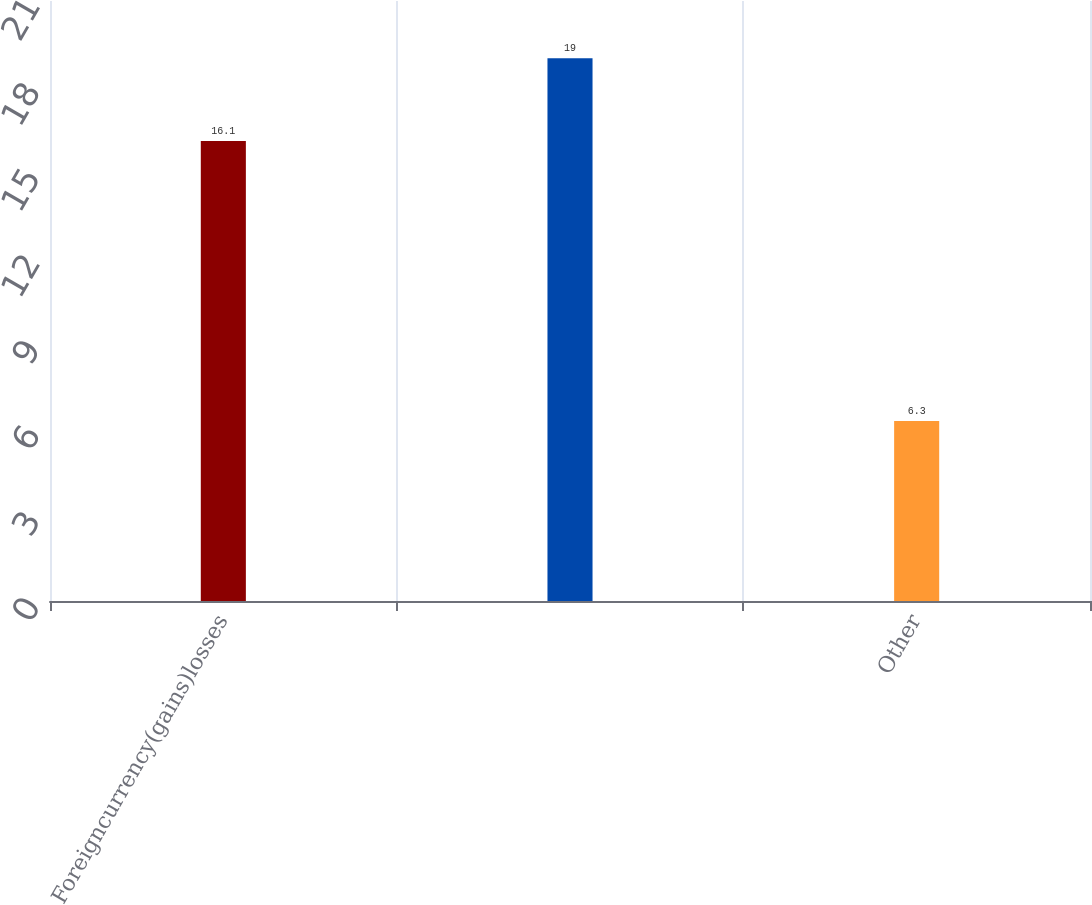Convert chart to OTSL. <chart><loc_0><loc_0><loc_500><loc_500><bar_chart><fcel>Foreigncurrency(gains)losses<fcel>Unnamed: 1<fcel>Other<nl><fcel>16.1<fcel>19<fcel>6.3<nl></chart> 